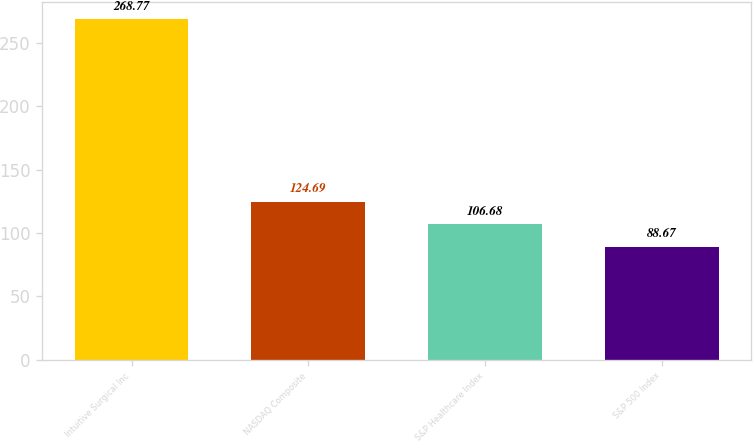Convert chart. <chart><loc_0><loc_0><loc_500><loc_500><bar_chart><fcel>Intuitive Surgical Inc<fcel>NASDAQ Composite<fcel>S&P Healthcare Index<fcel>S&P 500 Index<nl><fcel>268.77<fcel>124.69<fcel>106.68<fcel>88.67<nl></chart> 